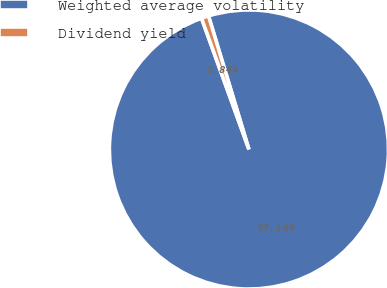<chart> <loc_0><loc_0><loc_500><loc_500><pie_chart><fcel>Weighted average volatility<fcel>Dividend yield<nl><fcel>99.16%<fcel>0.84%<nl></chart> 